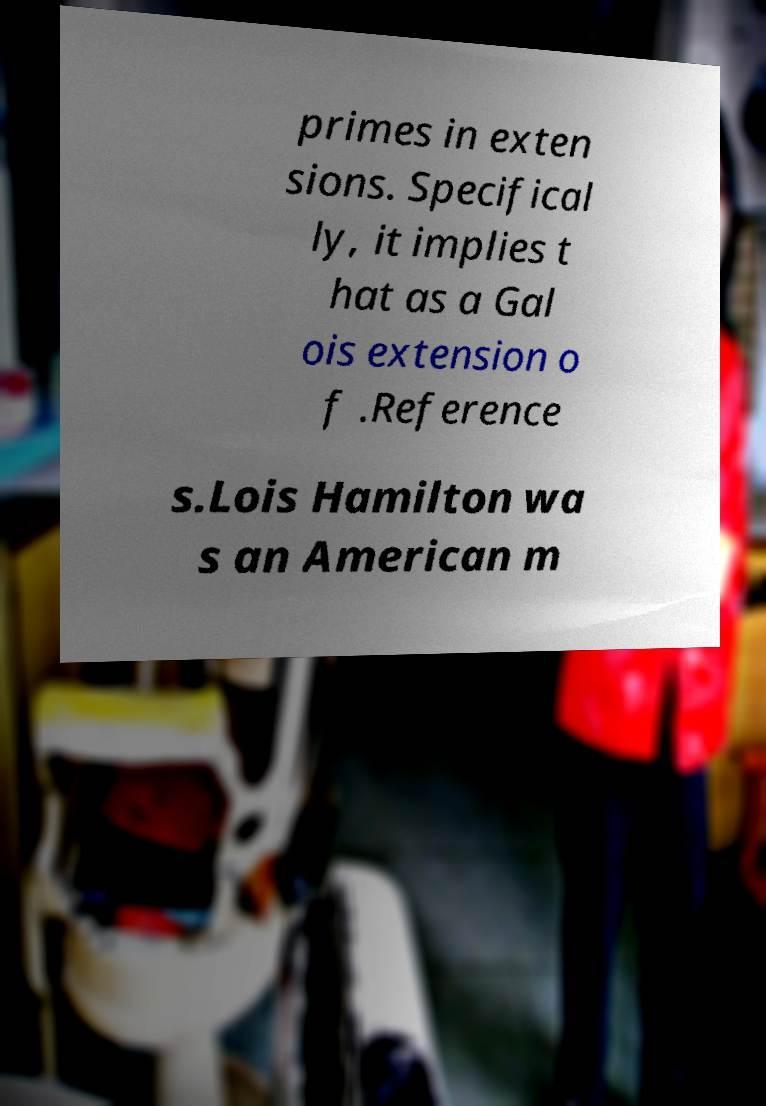Can you accurately transcribe the text from the provided image for me? primes in exten sions. Specifical ly, it implies t hat as a Gal ois extension o f .Reference s.Lois Hamilton wa s an American m 